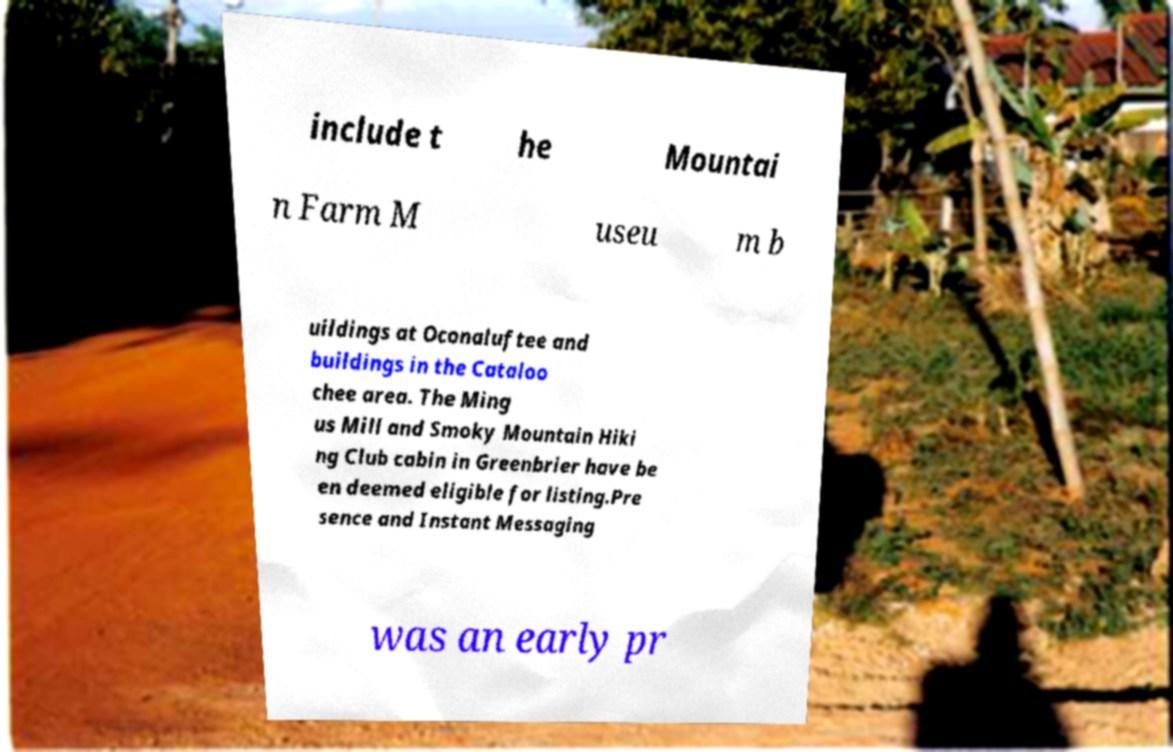Please read and relay the text visible in this image. What does it say? include t he Mountai n Farm M useu m b uildings at Oconaluftee and buildings in the Cataloo chee area. The Ming us Mill and Smoky Mountain Hiki ng Club cabin in Greenbrier have be en deemed eligible for listing.Pre sence and Instant Messaging was an early pr 